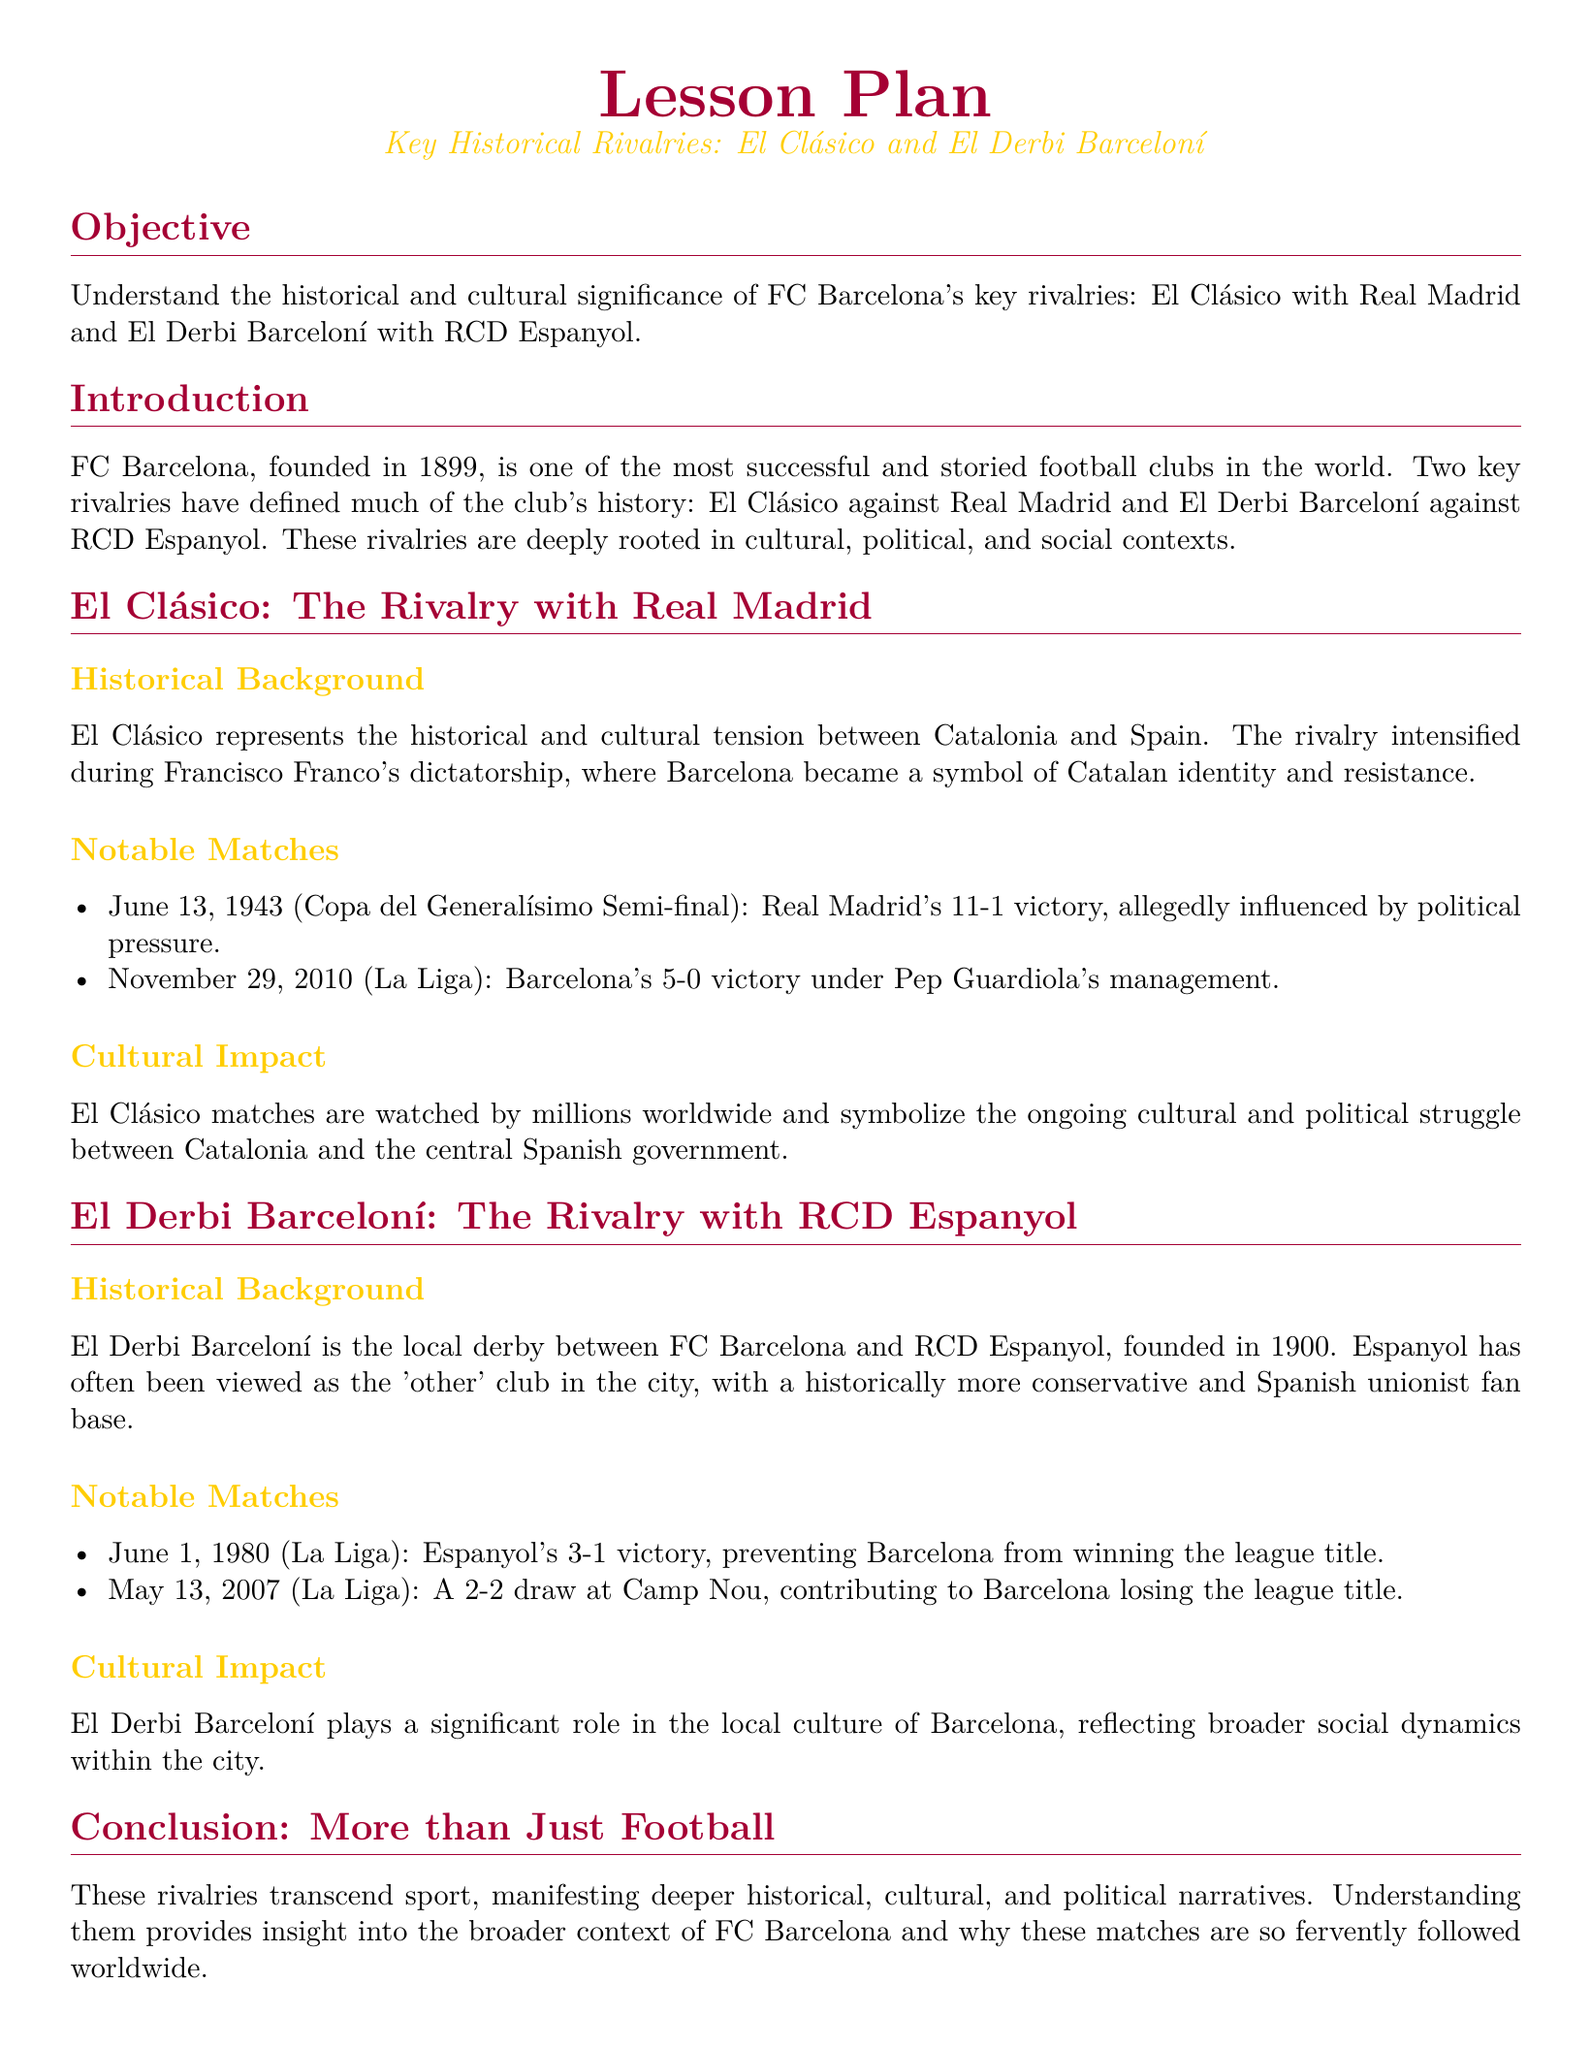What is the main objective of the lesson plan? The main objective is to understand the historical and cultural significance of FC Barcelona's key rivalries.
Answer: Understand the historical and cultural significance of FC Barcelona's key rivalries When was FC Barcelona founded? The document states that FC Barcelona was founded in 1899.
Answer: 1899 What significant event occurred on June 13, 1943, in El Clásico? The document mentions Real Madrid's 11-1 victory, which was allegedly influenced by political pressure.
Answer: Real Madrid's 11-1 victory Which manager led Barcelona to a 5-0 victory on November 29, 2010? The lesson plan specifies that this match occurred under Pep Guardiola's management.
Answer: Pep Guardiola What is El Derbi Barceloní? The document defines it as the local derby between FC Barcelona and RCD Espanyol.
Answer: The local derby between FC Barcelona and RCD Espanyol What year did Espanyol prevent Barcelona from winning the league title with a 3-1 victory? The document states this occurred in 1980.
Answer: 1980 How is El Clásico described in relation to cultural and political struggle? The document indicates that El Clásico symbolizes the ongoing cultural and political struggle between Catalonia and the central Spanish government.
Answer: Symbolizes the ongoing cultural and political struggle What historical context intensifies the rivalry in El Clásico? The document highlights that the rivalry intensified during Francisco Franco's dictatorship.
Answer: Francisco Franco's dictatorship What does the conclusion section emphasize about the rivalries? The conclusion emphasizes that these rivalries transcend sport, manifesting deeper historical, cultural, and political narratives.
Answer: Transcend sport, manifest deeper historical, cultural, and political narratives 